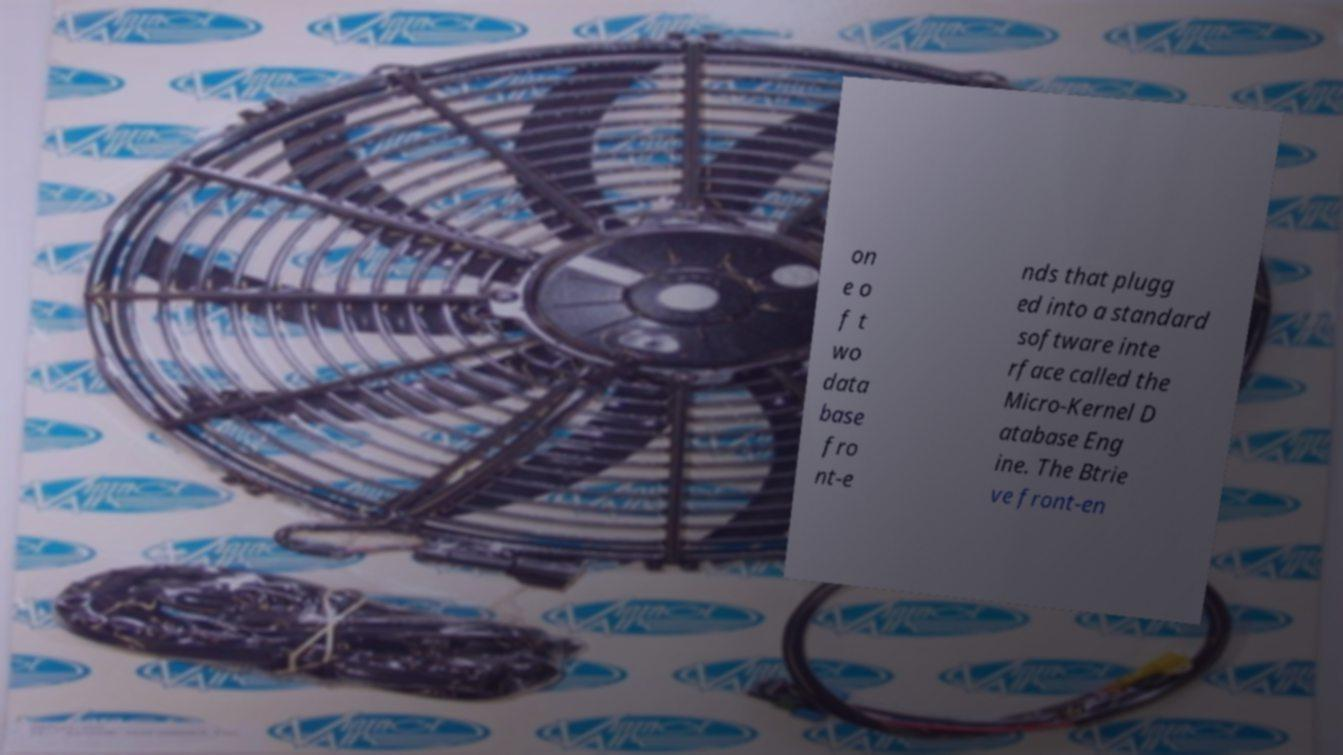Could you extract and type out the text from this image? on e o f t wo data base fro nt-e nds that plugg ed into a standard software inte rface called the Micro-Kernel D atabase Eng ine. The Btrie ve front-en 